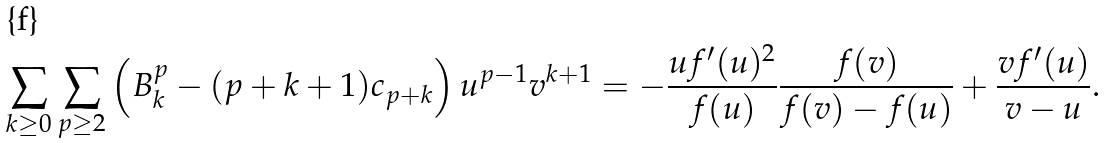<formula> <loc_0><loc_0><loc_500><loc_500>\sum _ { k \geq 0 } \sum _ { p \geq 2 } \left ( B _ { k } ^ { p } - ( p + k + 1 ) c _ { p + k } \right ) u ^ { p - 1 } v ^ { k + 1 } = - \frac { u f ^ { \prime } ( u ) ^ { 2 } } { f ( u ) } \frac { f ( v ) } { f ( v ) - f ( u ) } + \frac { v f ^ { \prime } ( u ) } { v - u } .</formula> 